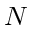<formula> <loc_0><loc_0><loc_500><loc_500>N</formula> 